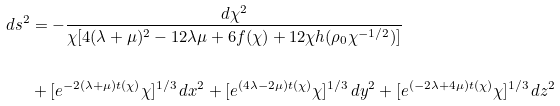Convert formula to latex. <formula><loc_0><loc_0><loc_500><loc_500>d s ^ { 2 } & = - \frac { d \chi ^ { 2 } } { \chi [ 4 ( \lambda + \mu ) ^ { 2 } - 1 2 \lambda \mu + 6 f ( \chi ) + 1 2 \chi h ( \rho _ { 0 } \chi ^ { - 1 / 2 } ) ] } \\ & \\ & + [ e ^ { - 2 ( \lambda + \mu ) t ( \chi ) } \chi ] ^ { 1 / 3 } \, d x ^ { 2 } + [ e ^ { ( 4 \lambda - 2 \mu ) t ( \chi ) } \chi ] ^ { 1 / 3 } \, d y ^ { 2 } + [ e ^ { ( - 2 \lambda + 4 \mu ) t ( \chi ) } \chi ] ^ { 1 / 3 } \, d z ^ { 2 }</formula> 